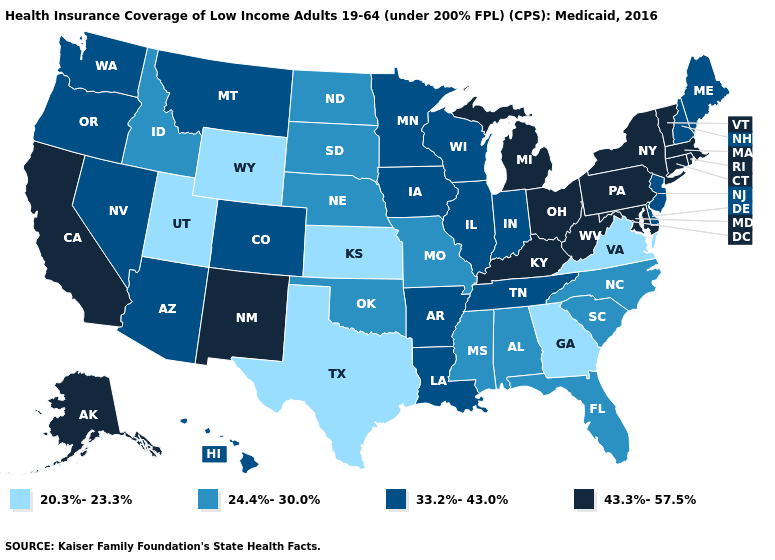Which states hav the highest value in the West?
Give a very brief answer. Alaska, California, New Mexico. Name the states that have a value in the range 20.3%-23.3%?
Short answer required. Georgia, Kansas, Texas, Utah, Virginia, Wyoming. Name the states that have a value in the range 33.2%-43.0%?
Short answer required. Arizona, Arkansas, Colorado, Delaware, Hawaii, Illinois, Indiana, Iowa, Louisiana, Maine, Minnesota, Montana, Nevada, New Hampshire, New Jersey, Oregon, Tennessee, Washington, Wisconsin. Which states have the lowest value in the USA?
Be succinct. Georgia, Kansas, Texas, Utah, Virginia, Wyoming. What is the highest value in the Northeast ?
Write a very short answer. 43.3%-57.5%. Name the states that have a value in the range 20.3%-23.3%?
Keep it brief. Georgia, Kansas, Texas, Utah, Virginia, Wyoming. Name the states that have a value in the range 33.2%-43.0%?
Write a very short answer. Arizona, Arkansas, Colorado, Delaware, Hawaii, Illinois, Indiana, Iowa, Louisiana, Maine, Minnesota, Montana, Nevada, New Hampshire, New Jersey, Oregon, Tennessee, Washington, Wisconsin. Which states have the lowest value in the USA?
Give a very brief answer. Georgia, Kansas, Texas, Utah, Virginia, Wyoming. Does the map have missing data?
Be succinct. No. Does the first symbol in the legend represent the smallest category?
Keep it brief. Yes. How many symbols are there in the legend?
Concise answer only. 4. Name the states that have a value in the range 33.2%-43.0%?
Be succinct. Arizona, Arkansas, Colorado, Delaware, Hawaii, Illinois, Indiana, Iowa, Louisiana, Maine, Minnesota, Montana, Nevada, New Hampshire, New Jersey, Oregon, Tennessee, Washington, Wisconsin. Does the first symbol in the legend represent the smallest category?
Give a very brief answer. Yes. Name the states that have a value in the range 20.3%-23.3%?
Keep it brief. Georgia, Kansas, Texas, Utah, Virginia, Wyoming. Does California have the highest value in the USA?
Quick response, please. Yes. 